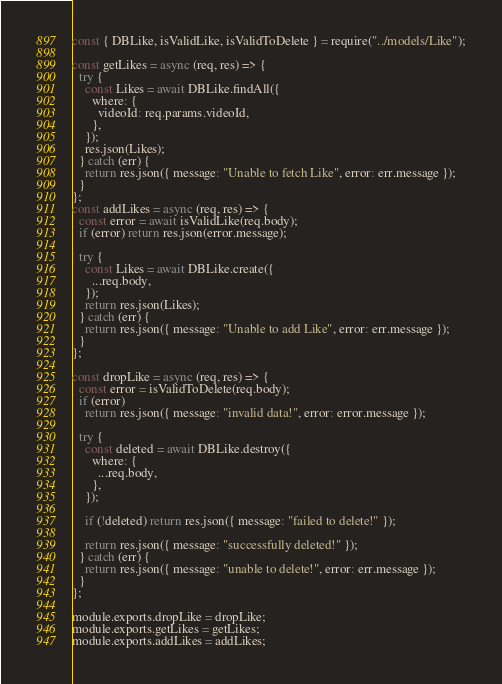Convert code to text. <code><loc_0><loc_0><loc_500><loc_500><_JavaScript_>const { DBLike, isValidLike, isValidToDelete } = require("../models/Like");

const getLikes = async (req, res) => {
  try {
    const Likes = await DBLike.findAll({
      where: {
        videoId: req.params.videoId,
      },
    });
    res.json(Likes);
  } catch (err) {
    return res.json({ message: "Unable to fetch Like", error: err.message });
  }
};
const addLikes = async (req, res) => {
  const error = await isValidLike(req.body);
  if (error) return res.json(error.message);

  try {
    const Likes = await DBLike.create({
      ...req.body,
    });
    return res.json(Likes);
  } catch (err) {
    return res.json({ message: "Unable to add Like", error: err.message });
  }
};

const dropLike = async (req, res) => {
  const error = isValidToDelete(req.body);
  if (error)
    return res.json({ message: "invalid data!", error: error.message });

  try {
    const deleted = await DBLike.destroy({
      where: {
        ...req.body,
      },
    });

    if (!deleted) return res.json({ message: "failed to delete!" });

    return res.json({ message: "successfully deleted!" });
  } catch (err) {
    return res.json({ message: "unable to delete!", error: err.message });
  }
};

module.exports.dropLike = dropLike;
module.exports.getLikes = getLikes;
module.exports.addLikes = addLikes;
</code> 